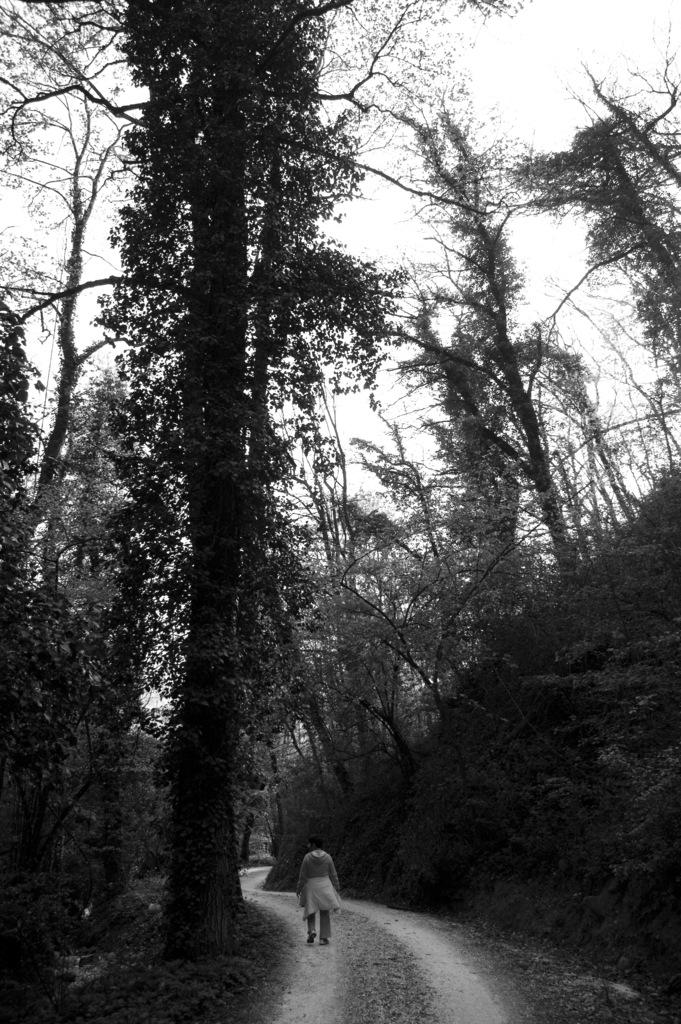What is the color scheme of the image? The image is black and white. Can you describe the main subject in the image? There is a person in the image. What can be seen under the person's feet? The ground is visible in the image. What type of vegetation is present in the image? There are trees and plants in the image. What is visible above the person and the trees? The sky is visible in the image. How many soldiers are present in the image? There is no army or soldiers present in the image; it features a person in a black and white setting with trees, plants, and the sky visible. 